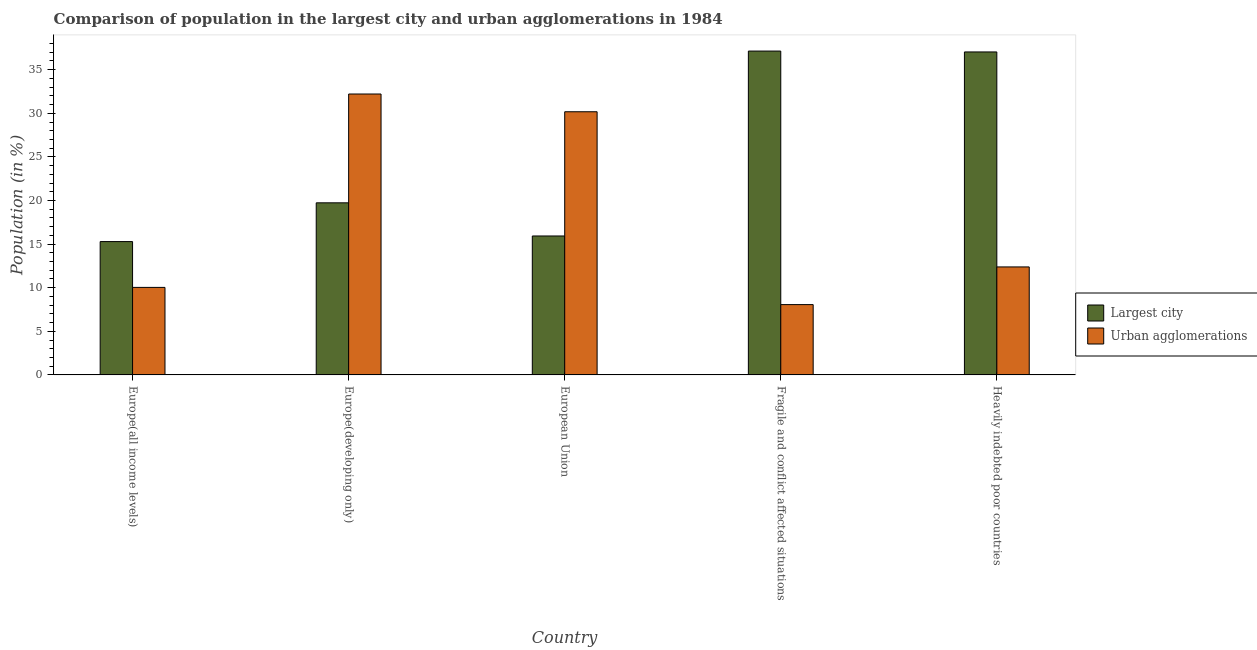How many different coloured bars are there?
Your response must be concise. 2. How many groups of bars are there?
Your answer should be very brief. 5. Are the number of bars on each tick of the X-axis equal?
Ensure brevity in your answer.  Yes. How many bars are there on the 5th tick from the right?
Offer a terse response. 2. In how many cases, is the number of bars for a given country not equal to the number of legend labels?
Keep it short and to the point. 0. What is the population in the largest city in European Union?
Your answer should be very brief. 15.93. Across all countries, what is the maximum population in urban agglomerations?
Ensure brevity in your answer.  32.21. Across all countries, what is the minimum population in urban agglomerations?
Your answer should be compact. 8.06. In which country was the population in urban agglomerations maximum?
Your response must be concise. Europe(developing only). In which country was the population in urban agglomerations minimum?
Provide a succinct answer. Fragile and conflict affected situations. What is the total population in urban agglomerations in the graph?
Keep it short and to the point. 92.87. What is the difference between the population in urban agglomerations in Europe(all income levels) and that in European Union?
Your answer should be compact. -20.14. What is the difference between the population in the largest city in Europe(all income levels) and the population in urban agglomerations in Heavily indebted poor countries?
Make the answer very short. 2.9. What is the average population in the largest city per country?
Your response must be concise. 25.02. What is the difference between the population in urban agglomerations and population in the largest city in Europe(developing only)?
Your answer should be compact. 12.48. In how many countries, is the population in the largest city greater than 22 %?
Your answer should be compact. 2. What is the ratio of the population in the largest city in Fragile and conflict affected situations to that in Heavily indebted poor countries?
Your answer should be compact. 1. What is the difference between the highest and the second highest population in urban agglomerations?
Make the answer very short. 2.04. What is the difference between the highest and the lowest population in urban agglomerations?
Ensure brevity in your answer.  24.15. What does the 1st bar from the left in Fragile and conflict affected situations represents?
Offer a very short reply. Largest city. What does the 2nd bar from the right in Heavily indebted poor countries represents?
Your answer should be compact. Largest city. How many bars are there?
Offer a very short reply. 10. What is the difference between two consecutive major ticks on the Y-axis?
Make the answer very short. 5. Does the graph contain any zero values?
Your answer should be very brief. No. How are the legend labels stacked?
Ensure brevity in your answer.  Vertical. What is the title of the graph?
Provide a short and direct response. Comparison of population in the largest city and urban agglomerations in 1984. What is the label or title of the X-axis?
Provide a succinct answer. Country. What is the Population (in %) of Largest city in Europe(all income levels)?
Provide a short and direct response. 15.29. What is the Population (in %) of Urban agglomerations in Europe(all income levels)?
Make the answer very short. 10.04. What is the Population (in %) of Largest city in Europe(developing only)?
Provide a short and direct response. 19.73. What is the Population (in %) of Urban agglomerations in Europe(developing only)?
Ensure brevity in your answer.  32.21. What is the Population (in %) in Largest city in European Union?
Give a very brief answer. 15.93. What is the Population (in %) in Urban agglomerations in European Union?
Provide a succinct answer. 30.18. What is the Population (in %) in Largest city in Fragile and conflict affected situations?
Offer a terse response. 37.14. What is the Population (in %) in Urban agglomerations in Fragile and conflict affected situations?
Offer a terse response. 8.06. What is the Population (in %) in Largest city in Heavily indebted poor countries?
Offer a very short reply. 37.03. What is the Population (in %) of Urban agglomerations in Heavily indebted poor countries?
Your response must be concise. 12.38. Across all countries, what is the maximum Population (in %) of Largest city?
Your response must be concise. 37.14. Across all countries, what is the maximum Population (in %) of Urban agglomerations?
Your response must be concise. 32.21. Across all countries, what is the minimum Population (in %) in Largest city?
Your response must be concise. 15.29. Across all countries, what is the minimum Population (in %) in Urban agglomerations?
Make the answer very short. 8.06. What is the total Population (in %) of Largest city in the graph?
Offer a very short reply. 125.12. What is the total Population (in %) of Urban agglomerations in the graph?
Your answer should be compact. 92.87. What is the difference between the Population (in %) of Largest city in Europe(all income levels) and that in Europe(developing only)?
Make the answer very short. -4.45. What is the difference between the Population (in %) in Urban agglomerations in Europe(all income levels) and that in Europe(developing only)?
Give a very brief answer. -22.18. What is the difference between the Population (in %) of Largest city in Europe(all income levels) and that in European Union?
Your answer should be compact. -0.64. What is the difference between the Population (in %) in Urban agglomerations in Europe(all income levels) and that in European Union?
Provide a short and direct response. -20.14. What is the difference between the Population (in %) of Largest city in Europe(all income levels) and that in Fragile and conflict affected situations?
Your response must be concise. -21.85. What is the difference between the Population (in %) of Urban agglomerations in Europe(all income levels) and that in Fragile and conflict affected situations?
Make the answer very short. 1.97. What is the difference between the Population (in %) of Largest city in Europe(all income levels) and that in Heavily indebted poor countries?
Provide a succinct answer. -21.75. What is the difference between the Population (in %) in Urban agglomerations in Europe(all income levels) and that in Heavily indebted poor countries?
Your response must be concise. -2.35. What is the difference between the Population (in %) in Largest city in Europe(developing only) and that in European Union?
Provide a succinct answer. 3.8. What is the difference between the Population (in %) in Urban agglomerations in Europe(developing only) and that in European Union?
Your answer should be very brief. 2.04. What is the difference between the Population (in %) of Largest city in Europe(developing only) and that in Fragile and conflict affected situations?
Give a very brief answer. -17.4. What is the difference between the Population (in %) of Urban agglomerations in Europe(developing only) and that in Fragile and conflict affected situations?
Your answer should be compact. 24.15. What is the difference between the Population (in %) in Largest city in Europe(developing only) and that in Heavily indebted poor countries?
Your answer should be compact. -17.3. What is the difference between the Population (in %) of Urban agglomerations in Europe(developing only) and that in Heavily indebted poor countries?
Your response must be concise. 19.83. What is the difference between the Population (in %) in Largest city in European Union and that in Fragile and conflict affected situations?
Keep it short and to the point. -21.2. What is the difference between the Population (in %) of Urban agglomerations in European Union and that in Fragile and conflict affected situations?
Provide a short and direct response. 22.12. What is the difference between the Population (in %) in Largest city in European Union and that in Heavily indebted poor countries?
Your response must be concise. -21.1. What is the difference between the Population (in %) of Urban agglomerations in European Union and that in Heavily indebted poor countries?
Your answer should be very brief. 17.79. What is the difference between the Population (in %) in Largest city in Fragile and conflict affected situations and that in Heavily indebted poor countries?
Your answer should be compact. 0.1. What is the difference between the Population (in %) of Urban agglomerations in Fragile and conflict affected situations and that in Heavily indebted poor countries?
Your answer should be very brief. -4.32. What is the difference between the Population (in %) of Largest city in Europe(all income levels) and the Population (in %) of Urban agglomerations in Europe(developing only)?
Give a very brief answer. -16.92. What is the difference between the Population (in %) of Largest city in Europe(all income levels) and the Population (in %) of Urban agglomerations in European Union?
Give a very brief answer. -14.89. What is the difference between the Population (in %) in Largest city in Europe(all income levels) and the Population (in %) in Urban agglomerations in Fragile and conflict affected situations?
Your response must be concise. 7.23. What is the difference between the Population (in %) of Largest city in Europe(all income levels) and the Population (in %) of Urban agglomerations in Heavily indebted poor countries?
Make the answer very short. 2.9. What is the difference between the Population (in %) in Largest city in Europe(developing only) and the Population (in %) in Urban agglomerations in European Union?
Provide a succinct answer. -10.44. What is the difference between the Population (in %) in Largest city in Europe(developing only) and the Population (in %) in Urban agglomerations in Fragile and conflict affected situations?
Give a very brief answer. 11.67. What is the difference between the Population (in %) of Largest city in Europe(developing only) and the Population (in %) of Urban agglomerations in Heavily indebted poor countries?
Provide a succinct answer. 7.35. What is the difference between the Population (in %) in Largest city in European Union and the Population (in %) in Urban agglomerations in Fragile and conflict affected situations?
Your answer should be very brief. 7.87. What is the difference between the Population (in %) of Largest city in European Union and the Population (in %) of Urban agglomerations in Heavily indebted poor countries?
Your response must be concise. 3.55. What is the difference between the Population (in %) of Largest city in Fragile and conflict affected situations and the Population (in %) of Urban agglomerations in Heavily indebted poor countries?
Offer a very short reply. 24.75. What is the average Population (in %) of Largest city per country?
Your response must be concise. 25.02. What is the average Population (in %) in Urban agglomerations per country?
Ensure brevity in your answer.  18.57. What is the difference between the Population (in %) of Largest city and Population (in %) of Urban agglomerations in Europe(all income levels)?
Ensure brevity in your answer.  5.25. What is the difference between the Population (in %) in Largest city and Population (in %) in Urban agglomerations in Europe(developing only)?
Ensure brevity in your answer.  -12.48. What is the difference between the Population (in %) in Largest city and Population (in %) in Urban agglomerations in European Union?
Offer a terse response. -14.25. What is the difference between the Population (in %) of Largest city and Population (in %) of Urban agglomerations in Fragile and conflict affected situations?
Ensure brevity in your answer.  29.07. What is the difference between the Population (in %) of Largest city and Population (in %) of Urban agglomerations in Heavily indebted poor countries?
Ensure brevity in your answer.  24.65. What is the ratio of the Population (in %) of Largest city in Europe(all income levels) to that in Europe(developing only)?
Make the answer very short. 0.77. What is the ratio of the Population (in %) in Urban agglomerations in Europe(all income levels) to that in Europe(developing only)?
Provide a succinct answer. 0.31. What is the ratio of the Population (in %) in Largest city in Europe(all income levels) to that in European Union?
Ensure brevity in your answer.  0.96. What is the ratio of the Population (in %) in Urban agglomerations in Europe(all income levels) to that in European Union?
Ensure brevity in your answer.  0.33. What is the ratio of the Population (in %) in Largest city in Europe(all income levels) to that in Fragile and conflict affected situations?
Offer a terse response. 0.41. What is the ratio of the Population (in %) in Urban agglomerations in Europe(all income levels) to that in Fragile and conflict affected situations?
Give a very brief answer. 1.24. What is the ratio of the Population (in %) in Largest city in Europe(all income levels) to that in Heavily indebted poor countries?
Offer a terse response. 0.41. What is the ratio of the Population (in %) in Urban agglomerations in Europe(all income levels) to that in Heavily indebted poor countries?
Offer a terse response. 0.81. What is the ratio of the Population (in %) in Largest city in Europe(developing only) to that in European Union?
Keep it short and to the point. 1.24. What is the ratio of the Population (in %) of Urban agglomerations in Europe(developing only) to that in European Union?
Ensure brevity in your answer.  1.07. What is the ratio of the Population (in %) of Largest city in Europe(developing only) to that in Fragile and conflict affected situations?
Make the answer very short. 0.53. What is the ratio of the Population (in %) in Urban agglomerations in Europe(developing only) to that in Fragile and conflict affected situations?
Offer a very short reply. 4. What is the ratio of the Population (in %) in Largest city in Europe(developing only) to that in Heavily indebted poor countries?
Offer a terse response. 0.53. What is the ratio of the Population (in %) in Urban agglomerations in Europe(developing only) to that in Heavily indebted poor countries?
Provide a short and direct response. 2.6. What is the ratio of the Population (in %) in Largest city in European Union to that in Fragile and conflict affected situations?
Provide a short and direct response. 0.43. What is the ratio of the Population (in %) of Urban agglomerations in European Union to that in Fragile and conflict affected situations?
Ensure brevity in your answer.  3.74. What is the ratio of the Population (in %) of Largest city in European Union to that in Heavily indebted poor countries?
Provide a succinct answer. 0.43. What is the ratio of the Population (in %) of Urban agglomerations in European Union to that in Heavily indebted poor countries?
Keep it short and to the point. 2.44. What is the ratio of the Population (in %) of Largest city in Fragile and conflict affected situations to that in Heavily indebted poor countries?
Offer a very short reply. 1. What is the ratio of the Population (in %) of Urban agglomerations in Fragile and conflict affected situations to that in Heavily indebted poor countries?
Provide a succinct answer. 0.65. What is the difference between the highest and the second highest Population (in %) in Largest city?
Keep it short and to the point. 0.1. What is the difference between the highest and the second highest Population (in %) in Urban agglomerations?
Your answer should be very brief. 2.04. What is the difference between the highest and the lowest Population (in %) in Largest city?
Your response must be concise. 21.85. What is the difference between the highest and the lowest Population (in %) in Urban agglomerations?
Your answer should be very brief. 24.15. 